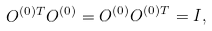Convert formula to latex. <formula><loc_0><loc_0><loc_500><loc_500>O ^ { ( 0 ) T } O ^ { ( 0 ) } = O ^ { ( 0 ) } O ^ { ( 0 ) T } = I ,</formula> 